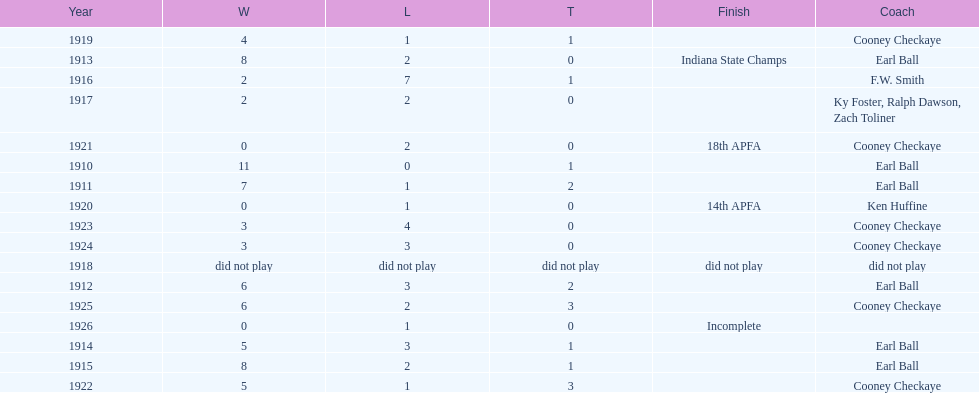Who coached the muncie flyers to an indiana state championship? Earl Ball. 